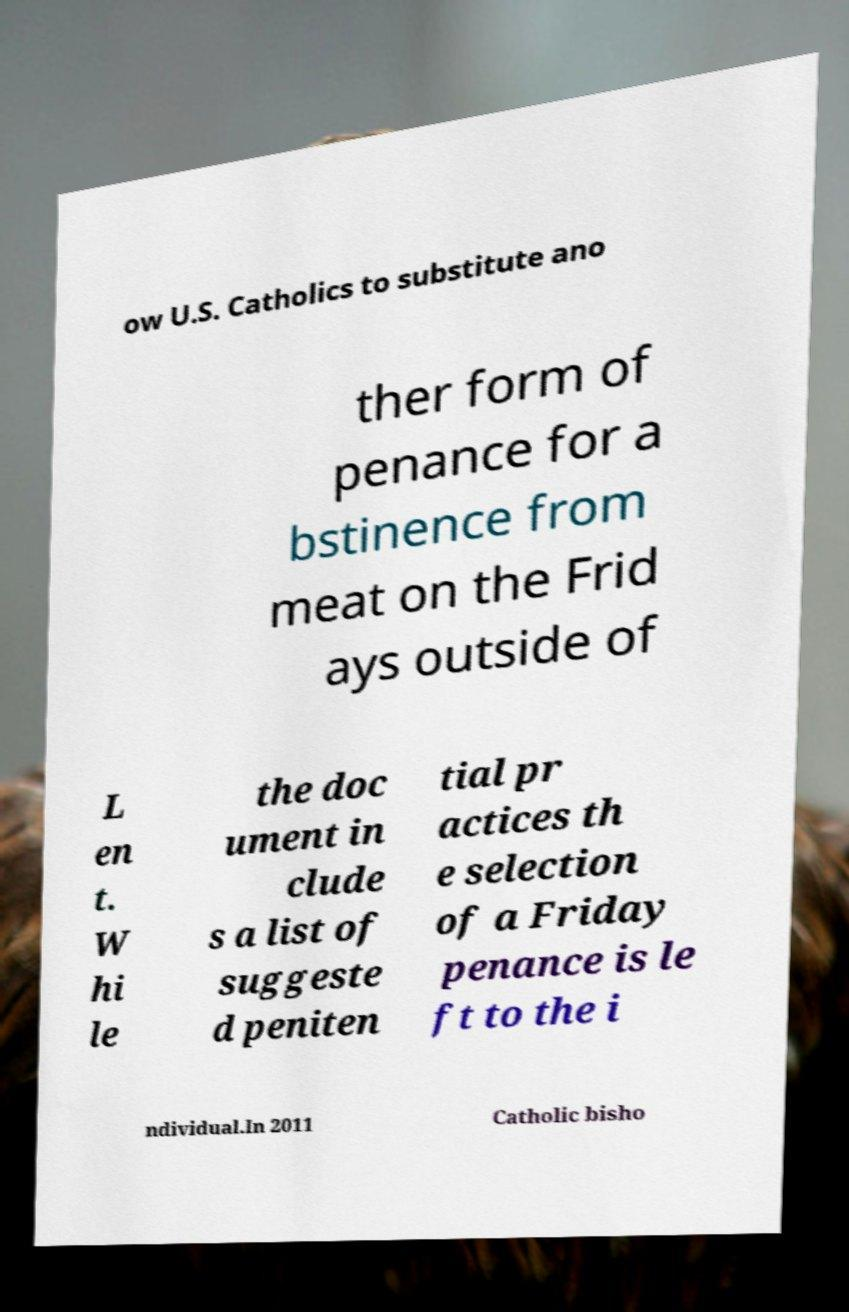Could you assist in decoding the text presented in this image and type it out clearly? ow U.S. Catholics to substitute ano ther form of penance for a bstinence from meat on the Frid ays outside of L en t. W hi le the doc ument in clude s a list of suggeste d peniten tial pr actices th e selection of a Friday penance is le ft to the i ndividual.In 2011 Catholic bisho 